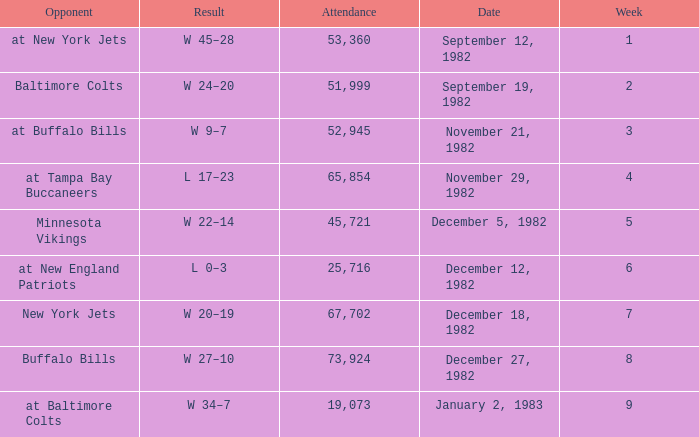What is the result of the game with an attendance greater than 67,702? W 27–10. 